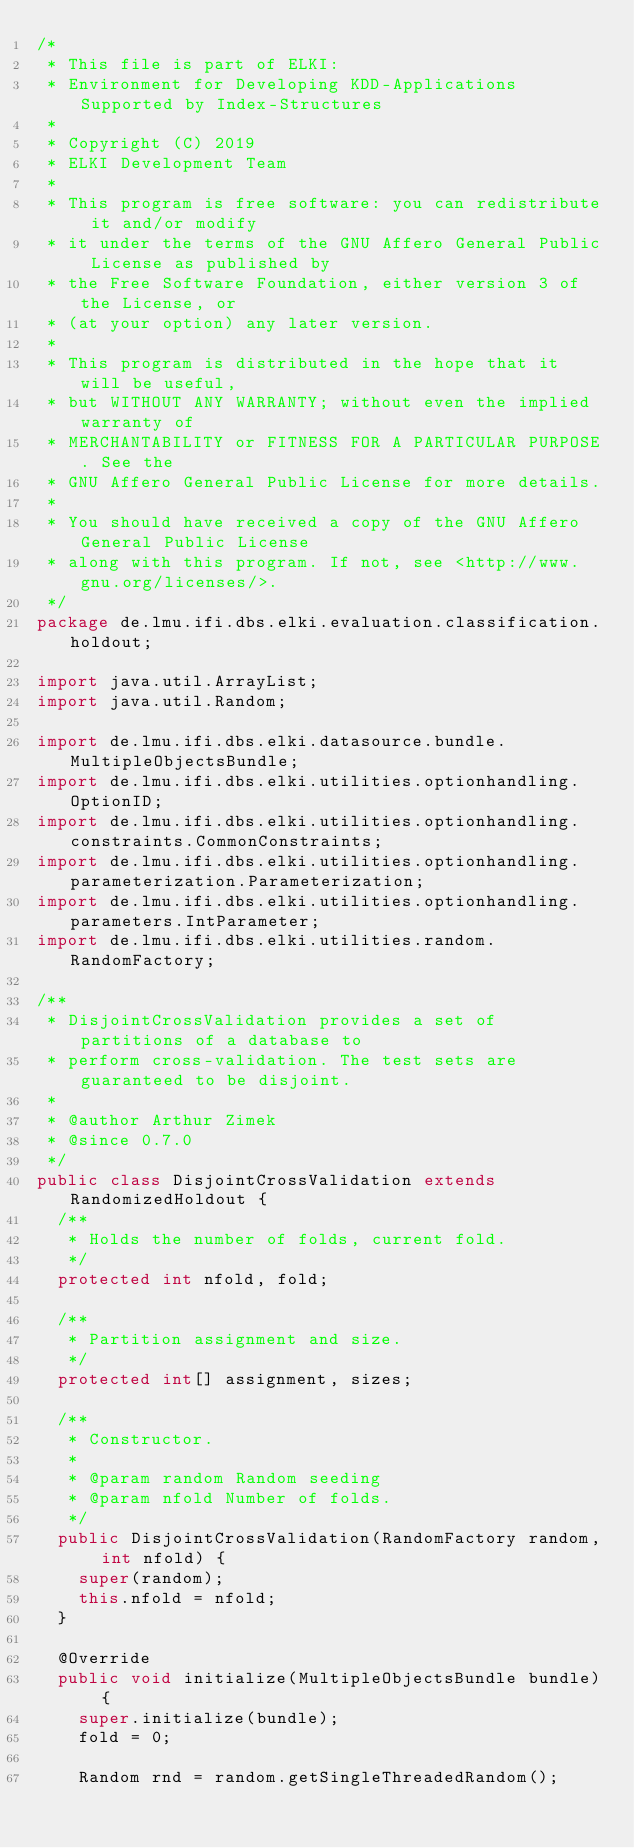Convert code to text. <code><loc_0><loc_0><loc_500><loc_500><_Java_>/*
 * This file is part of ELKI:
 * Environment for Developing KDD-Applications Supported by Index-Structures
 *
 * Copyright (C) 2019
 * ELKI Development Team
 *
 * This program is free software: you can redistribute it and/or modify
 * it under the terms of the GNU Affero General Public License as published by
 * the Free Software Foundation, either version 3 of the License, or
 * (at your option) any later version.
 *
 * This program is distributed in the hope that it will be useful,
 * but WITHOUT ANY WARRANTY; without even the implied warranty of
 * MERCHANTABILITY or FITNESS FOR A PARTICULAR PURPOSE. See the
 * GNU Affero General Public License for more details.
 *
 * You should have received a copy of the GNU Affero General Public License
 * along with this program. If not, see <http://www.gnu.org/licenses/>.
 */
package de.lmu.ifi.dbs.elki.evaluation.classification.holdout;

import java.util.ArrayList;
import java.util.Random;

import de.lmu.ifi.dbs.elki.datasource.bundle.MultipleObjectsBundle;
import de.lmu.ifi.dbs.elki.utilities.optionhandling.OptionID;
import de.lmu.ifi.dbs.elki.utilities.optionhandling.constraints.CommonConstraints;
import de.lmu.ifi.dbs.elki.utilities.optionhandling.parameterization.Parameterization;
import de.lmu.ifi.dbs.elki.utilities.optionhandling.parameters.IntParameter;
import de.lmu.ifi.dbs.elki.utilities.random.RandomFactory;

/**
 * DisjointCrossValidation provides a set of partitions of a database to
 * perform cross-validation. The test sets are guaranteed to be disjoint.
 * 
 * @author Arthur Zimek
 * @since 0.7.0
 */
public class DisjointCrossValidation extends RandomizedHoldout {
  /**
   * Holds the number of folds, current fold.
   */
  protected int nfold, fold;

  /**
   * Partition assignment and size.
   */
  protected int[] assignment, sizes;

  /**
   * Constructor.
   *
   * @param random Random seeding
   * @param nfold Number of folds.
   */
  public DisjointCrossValidation(RandomFactory random, int nfold) {
    super(random);
    this.nfold = nfold;
  }

  @Override
  public void initialize(MultipleObjectsBundle bundle) {
    super.initialize(bundle);
    fold = 0;

    Random rnd = random.getSingleThreadedRandom();</code> 